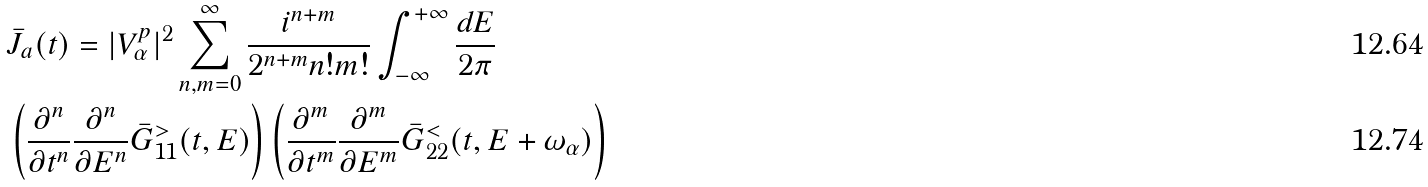<formula> <loc_0><loc_0><loc_500><loc_500>& \bar { J } _ { a } ( t ) = | V _ { \alpha } ^ { p } | ^ { 2 } \sum _ { n , m = 0 } ^ { \infty } \frac { i ^ { n + m } } { 2 ^ { n + m } n ! m ! } \int _ { - \infty } ^ { + \infty } \frac { d E } { 2 \pi } \\ & \left ( \frac { \partial ^ { n } } { \partial t ^ { n } } \frac { \partial ^ { n } } { \partial E ^ { n } } { \bar { G } } ^ { > } _ { 1 1 } ( t , E ) \right ) \left ( \frac { \partial ^ { m } } { \partial t ^ { m } } \frac { \partial ^ { m } } { \partial E ^ { m } } { \bar { G } } ^ { < } _ { 2 2 } ( t , E + \omega _ { \alpha } ) \right )</formula> 